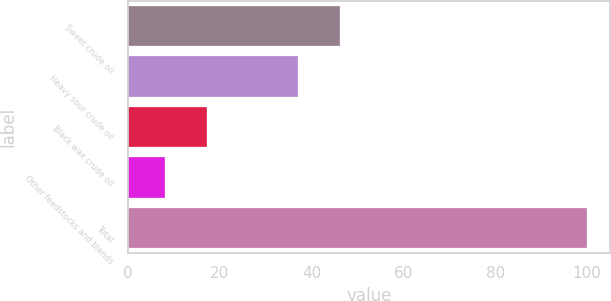Convert chart to OTSL. <chart><loc_0><loc_0><loc_500><loc_500><bar_chart><fcel>Sweet crude oil<fcel>Heavy sour crude oil<fcel>Black wax crude oil<fcel>Other feedstocks and blends<fcel>Total<nl><fcel>46.2<fcel>37<fcel>17.2<fcel>8<fcel>100<nl></chart> 